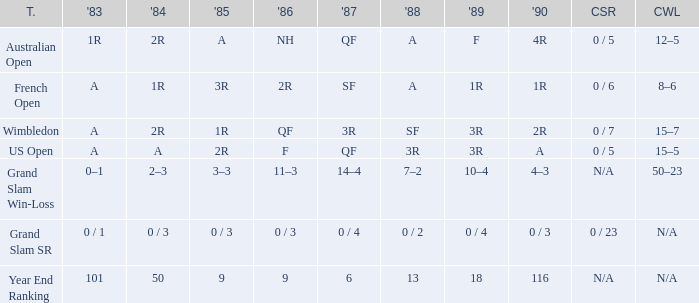What is the result in 1985 when the career win-loss is n/a, and 0 / 23 as the career SR? 0 / 3. 